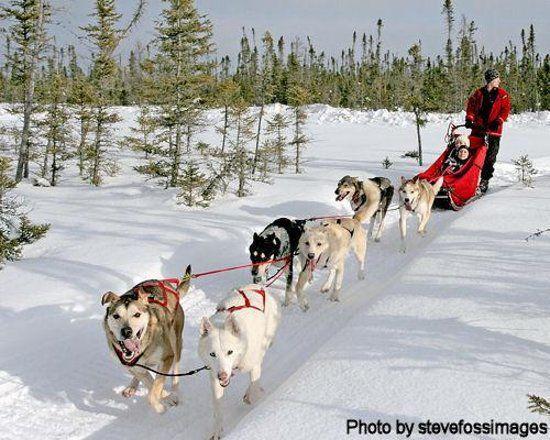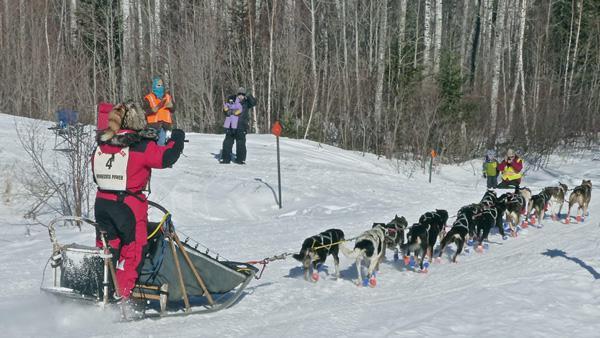The first image is the image on the left, the second image is the image on the right. For the images displayed, is the sentence "All the sled dogs in the left image are running towards the left." factually correct? Answer yes or no. Yes. The first image is the image on the left, the second image is the image on the right. Assess this claim about the two images: "A sled driver in red and black leads a team of dogs diagonally to the left past stands of evergreen trees.". Correct or not? Answer yes or no. Yes. 